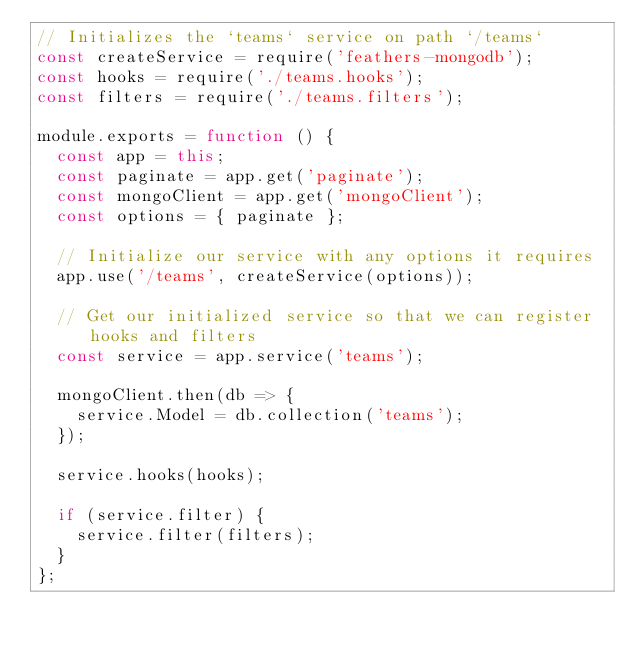Convert code to text. <code><loc_0><loc_0><loc_500><loc_500><_JavaScript_>// Initializes the `teams` service on path `/teams`
const createService = require('feathers-mongodb');
const hooks = require('./teams.hooks');
const filters = require('./teams.filters');

module.exports = function () {
  const app = this;
  const paginate = app.get('paginate');
  const mongoClient = app.get('mongoClient');
  const options = { paginate };

  // Initialize our service with any options it requires
  app.use('/teams', createService(options));

  // Get our initialized service so that we can register hooks and filters
  const service = app.service('teams');

  mongoClient.then(db => {
    service.Model = db.collection('teams');
  });

  service.hooks(hooks);

  if (service.filter) {
    service.filter(filters);
  }
};
</code> 